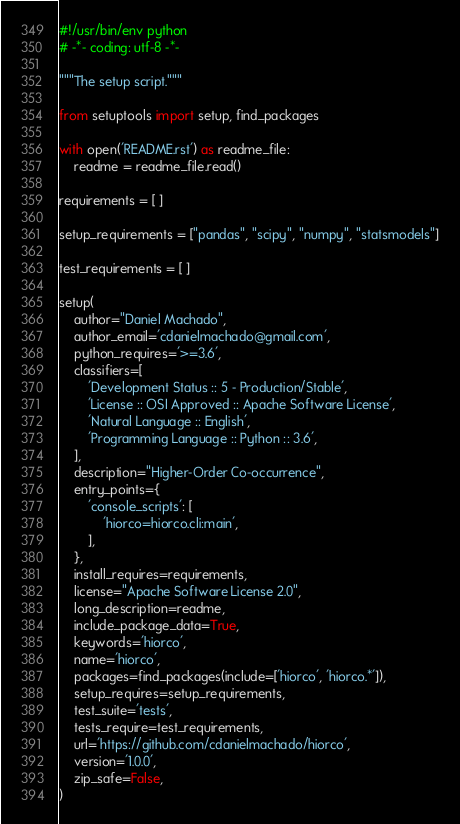<code> <loc_0><loc_0><loc_500><loc_500><_Python_>#!/usr/bin/env python
# -*- coding: utf-8 -*-

"""The setup script."""

from setuptools import setup, find_packages

with open('README.rst') as readme_file:
    readme = readme_file.read()

requirements = [ ]

setup_requirements = ["pandas", "scipy", "numpy", "statsmodels"]

test_requirements = [ ]

setup(
    author="Daniel Machado",
    author_email='cdanielmachado@gmail.com',
    python_requires='>=3.6',
    classifiers=[
        'Development Status :: 5 - Production/Stable',
        'License :: OSI Approved :: Apache Software License',
        'Natural Language :: English',
        'Programming Language :: Python :: 3.6',
    ],
    description="Higher-Order Co-occurrence",
    entry_points={
        'console_scripts': [
            'hiorco=hiorco.cli:main',
        ],
    },
    install_requires=requirements,
    license="Apache Software License 2.0",
    long_description=readme,
    include_package_data=True,
    keywords='hiorco',
    name='hiorco',
    packages=find_packages(include=['hiorco', 'hiorco.*']),
    setup_requires=setup_requirements,
    test_suite='tests',
    tests_require=test_requirements,
    url='https://github.com/cdanielmachado/hiorco',
    version='1.0.0',
    zip_safe=False,
)
</code> 